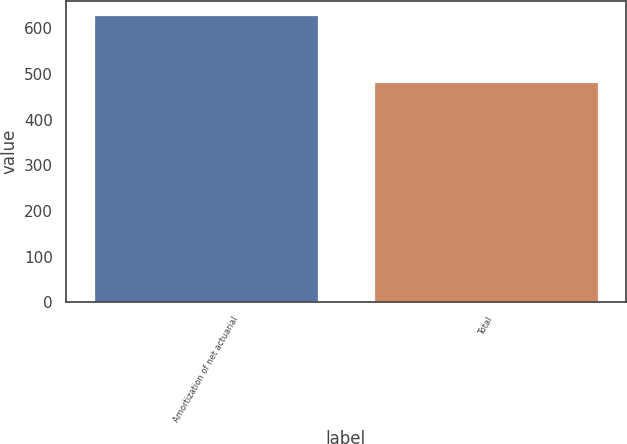Convert chart. <chart><loc_0><loc_0><loc_500><loc_500><bar_chart><fcel>Amortization of net actuarial<fcel>Total<nl><fcel>628<fcel>482<nl></chart> 